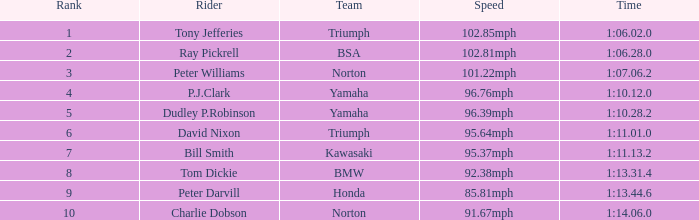What is the count of ranks for ray pickrell in his rider capacity? 1.0. 